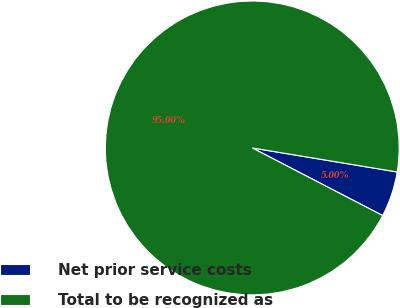Convert chart. <chart><loc_0><loc_0><loc_500><loc_500><pie_chart><fcel>Net prior service costs<fcel>Total to be recognized as<nl><fcel>5.0%<fcel>95.0%<nl></chart> 